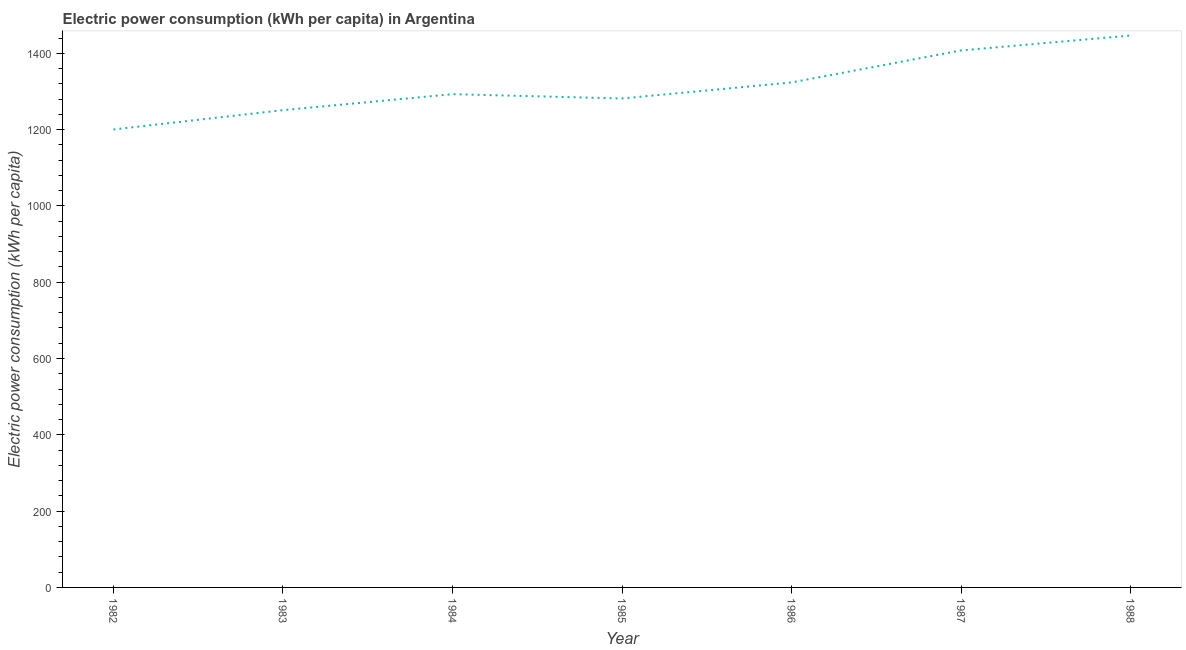What is the electric power consumption in 1988?
Your answer should be very brief. 1446.52. Across all years, what is the maximum electric power consumption?
Offer a terse response. 1446.52. Across all years, what is the minimum electric power consumption?
Keep it short and to the point. 1200.35. In which year was the electric power consumption maximum?
Make the answer very short. 1988. What is the sum of the electric power consumption?
Your answer should be compact. 9203.16. What is the difference between the electric power consumption in 1983 and 1985?
Give a very brief answer. -30.62. What is the average electric power consumption per year?
Give a very brief answer. 1314.74. What is the median electric power consumption?
Your answer should be very brief. 1292.81. In how many years, is the electric power consumption greater than 1280 kWh per capita?
Provide a succinct answer. 5. What is the ratio of the electric power consumption in 1984 to that in 1988?
Keep it short and to the point. 0.89. What is the difference between the highest and the second highest electric power consumption?
Offer a very short reply. 39.09. What is the difference between the highest and the lowest electric power consumption?
Ensure brevity in your answer.  246.17. Does the electric power consumption monotonically increase over the years?
Ensure brevity in your answer.  No. How many lines are there?
Make the answer very short. 1. Does the graph contain grids?
Keep it short and to the point. No. What is the title of the graph?
Offer a terse response. Electric power consumption (kWh per capita) in Argentina. What is the label or title of the Y-axis?
Make the answer very short. Electric power consumption (kWh per capita). What is the Electric power consumption (kWh per capita) in 1982?
Offer a terse response. 1200.35. What is the Electric power consumption (kWh per capita) of 1983?
Offer a terse response. 1250.94. What is the Electric power consumption (kWh per capita) of 1984?
Make the answer very short. 1292.81. What is the Electric power consumption (kWh per capita) of 1985?
Offer a terse response. 1281.56. What is the Electric power consumption (kWh per capita) in 1986?
Offer a very short reply. 1323.55. What is the Electric power consumption (kWh per capita) of 1987?
Provide a succinct answer. 1407.44. What is the Electric power consumption (kWh per capita) of 1988?
Your answer should be compact. 1446.52. What is the difference between the Electric power consumption (kWh per capita) in 1982 and 1983?
Keep it short and to the point. -50.58. What is the difference between the Electric power consumption (kWh per capita) in 1982 and 1984?
Provide a succinct answer. -92.46. What is the difference between the Electric power consumption (kWh per capita) in 1982 and 1985?
Your answer should be very brief. -81.21. What is the difference between the Electric power consumption (kWh per capita) in 1982 and 1986?
Your response must be concise. -123.19. What is the difference between the Electric power consumption (kWh per capita) in 1982 and 1987?
Provide a short and direct response. -207.08. What is the difference between the Electric power consumption (kWh per capita) in 1982 and 1988?
Offer a terse response. -246.17. What is the difference between the Electric power consumption (kWh per capita) in 1983 and 1984?
Make the answer very short. -41.87. What is the difference between the Electric power consumption (kWh per capita) in 1983 and 1985?
Offer a terse response. -30.62. What is the difference between the Electric power consumption (kWh per capita) in 1983 and 1986?
Offer a terse response. -72.61. What is the difference between the Electric power consumption (kWh per capita) in 1983 and 1987?
Ensure brevity in your answer.  -156.5. What is the difference between the Electric power consumption (kWh per capita) in 1983 and 1988?
Offer a terse response. -195.59. What is the difference between the Electric power consumption (kWh per capita) in 1984 and 1985?
Your answer should be very brief. 11.25. What is the difference between the Electric power consumption (kWh per capita) in 1984 and 1986?
Your answer should be very brief. -30.74. What is the difference between the Electric power consumption (kWh per capita) in 1984 and 1987?
Provide a succinct answer. -114.63. What is the difference between the Electric power consumption (kWh per capita) in 1984 and 1988?
Keep it short and to the point. -153.72. What is the difference between the Electric power consumption (kWh per capita) in 1985 and 1986?
Make the answer very short. -41.99. What is the difference between the Electric power consumption (kWh per capita) in 1985 and 1987?
Give a very brief answer. -125.88. What is the difference between the Electric power consumption (kWh per capita) in 1985 and 1988?
Provide a short and direct response. -164.97. What is the difference between the Electric power consumption (kWh per capita) in 1986 and 1987?
Your response must be concise. -83.89. What is the difference between the Electric power consumption (kWh per capita) in 1986 and 1988?
Your answer should be compact. -122.98. What is the difference between the Electric power consumption (kWh per capita) in 1987 and 1988?
Your response must be concise. -39.09. What is the ratio of the Electric power consumption (kWh per capita) in 1982 to that in 1983?
Keep it short and to the point. 0.96. What is the ratio of the Electric power consumption (kWh per capita) in 1982 to that in 1984?
Your answer should be very brief. 0.93. What is the ratio of the Electric power consumption (kWh per capita) in 1982 to that in 1985?
Your answer should be very brief. 0.94. What is the ratio of the Electric power consumption (kWh per capita) in 1982 to that in 1986?
Your answer should be very brief. 0.91. What is the ratio of the Electric power consumption (kWh per capita) in 1982 to that in 1987?
Give a very brief answer. 0.85. What is the ratio of the Electric power consumption (kWh per capita) in 1982 to that in 1988?
Provide a succinct answer. 0.83. What is the ratio of the Electric power consumption (kWh per capita) in 1983 to that in 1986?
Provide a succinct answer. 0.94. What is the ratio of the Electric power consumption (kWh per capita) in 1983 to that in 1987?
Provide a succinct answer. 0.89. What is the ratio of the Electric power consumption (kWh per capita) in 1983 to that in 1988?
Provide a short and direct response. 0.86. What is the ratio of the Electric power consumption (kWh per capita) in 1984 to that in 1985?
Ensure brevity in your answer.  1.01. What is the ratio of the Electric power consumption (kWh per capita) in 1984 to that in 1987?
Offer a very short reply. 0.92. What is the ratio of the Electric power consumption (kWh per capita) in 1984 to that in 1988?
Offer a terse response. 0.89. What is the ratio of the Electric power consumption (kWh per capita) in 1985 to that in 1987?
Provide a short and direct response. 0.91. What is the ratio of the Electric power consumption (kWh per capita) in 1985 to that in 1988?
Provide a succinct answer. 0.89. What is the ratio of the Electric power consumption (kWh per capita) in 1986 to that in 1988?
Offer a terse response. 0.92. What is the ratio of the Electric power consumption (kWh per capita) in 1987 to that in 1988?
Ensure brevity in your answer.  0.97. 